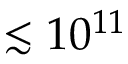<formula> <loc_0><loc_0><loc_500><loc_500>\lesssim 1 0 ^ { 1 1 }</formula> 